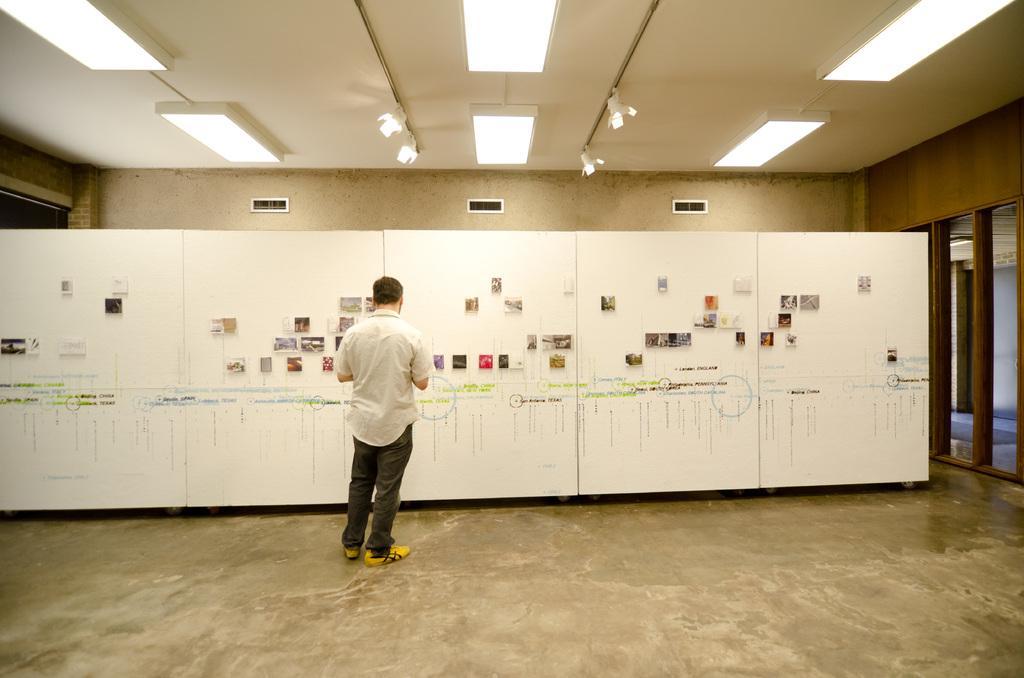How would you summarize this image in a sentence or two? In the center of the image we can see a man standing and there is a board. There are papers placed on the board. In the background there is a wall and a door. At the top there are lights. 